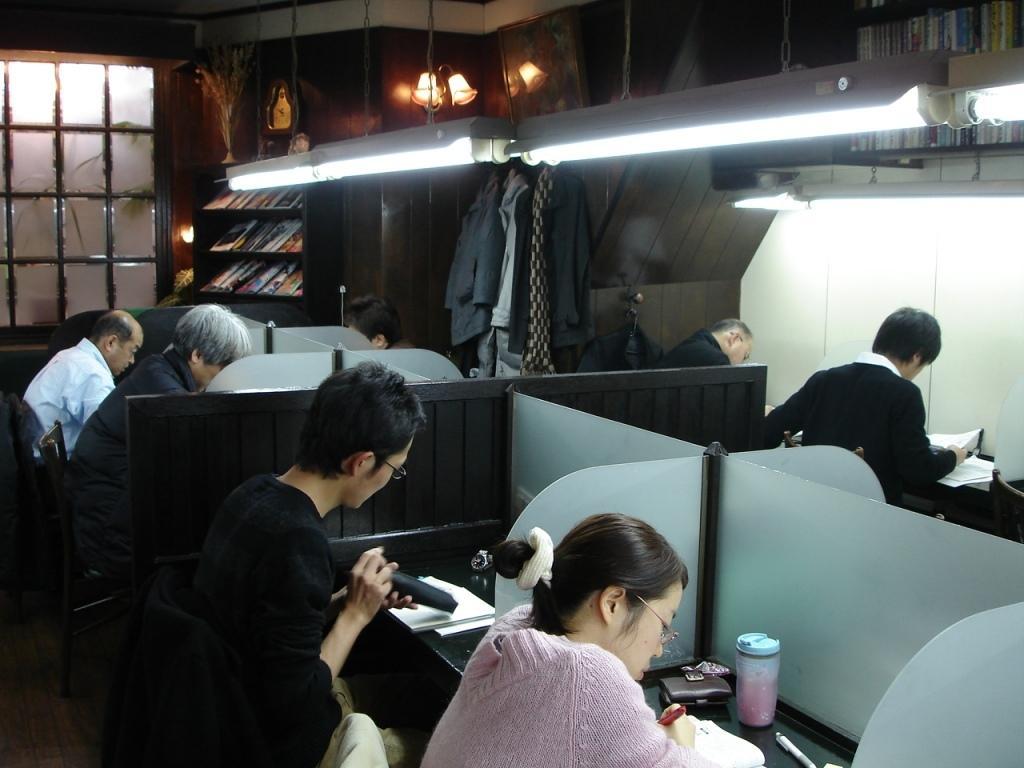Can you describe this image briefly? In the picture we can see inside the office with some cabins and some people sit-in the chairs and doing their work and to the ceiling we can see some lights are hanged and in the background, we can see a wall with a window and glass to it and beside it, we can see a rack with full of books in it and besides we can also see a hanger with some clothes to it. 